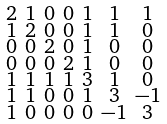<formula> <loc_0><loc_0><loc_500><loc_500>\begin{smallmatrix} 2 & 1 & 0 & 0 & 1 & 1 & 1 \\ 1 & 2 & 0 & 0 & 1 & 1 & 0 \\ 0 & 0 & 2 & 0 & 1 & 0 & 0 \\ 0 & 0 & 0 & 2 & 1 & 0 & 0 \\ 1 & 1 & 1 & 1 & 3 & 1 & 0 \\ 1 & 1 & 0 & 0 & 1 & 3 & - 1 \\ 1 & 0 & 0 & 0 & 0 & - 1 & 3 \end{smallmatrix}</formula> 